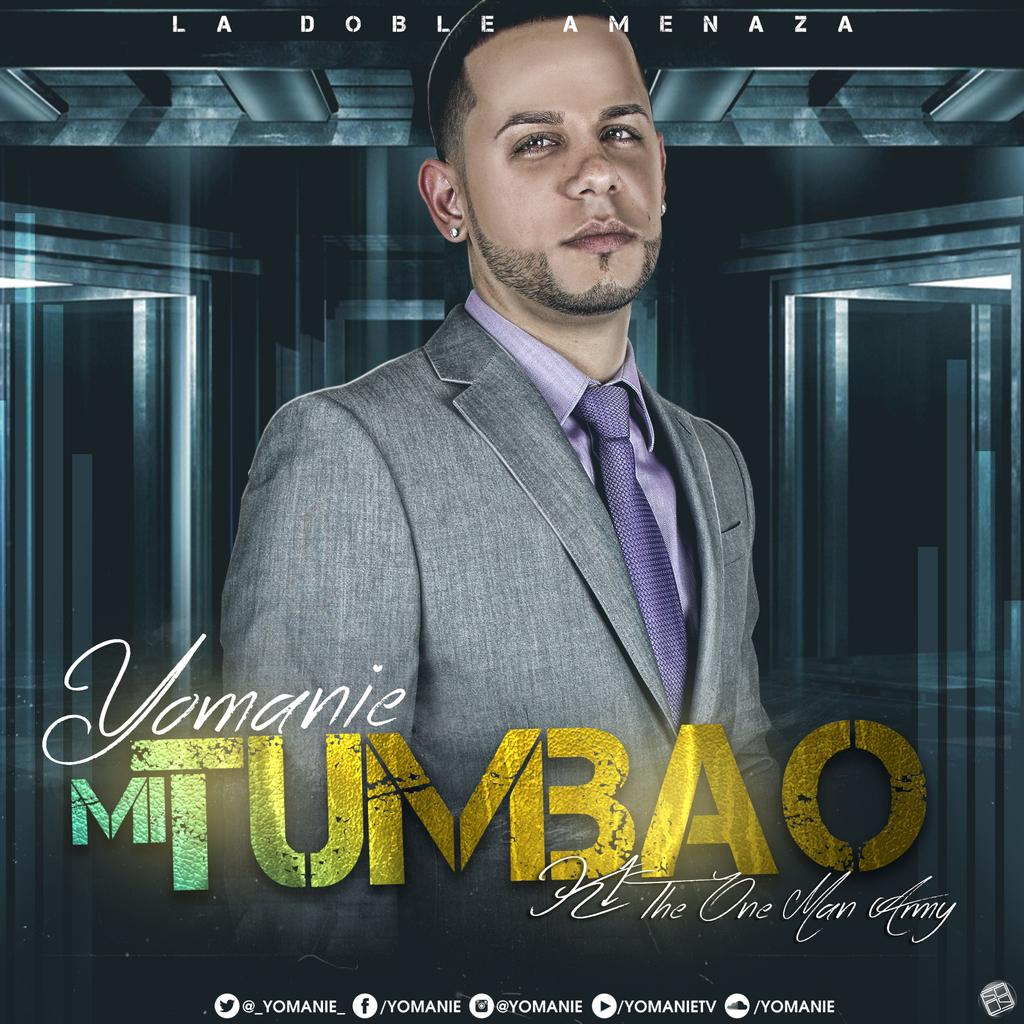What is the main subject of the poster in the image? The poster features a person. What type of clothing is the person wearing? The person is wearing a blazer, a shirt, and a purple color tie. What is the purpose of the edited text on the poster? The edited text on the poster provides additional information or context about the person featured. How many bears can be seen interacting with the person on the poster? There are no bears present on the poster; it features a person wearing a blazer, shirt, and purple color tie. What type of maid is depicted on the poster? There is no maid depicted on the poster; it features a person wearing a blazer, shirt, and purple color tie. 